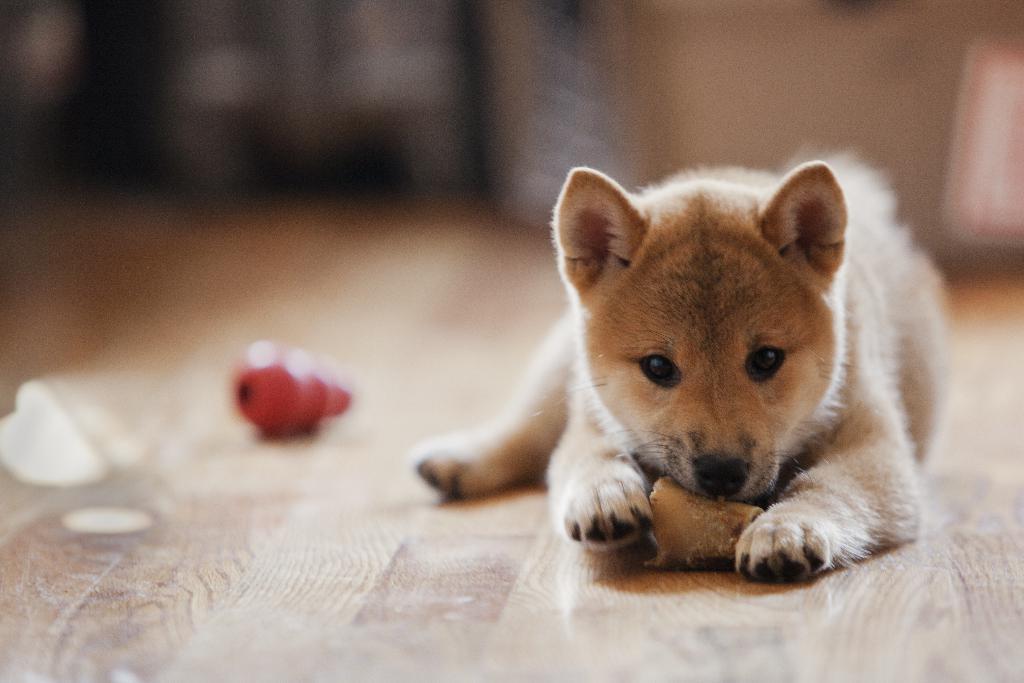Can you describe this image briefly? In this image we can see a dog is eating food. This is wooden floor. Background it is blur. 